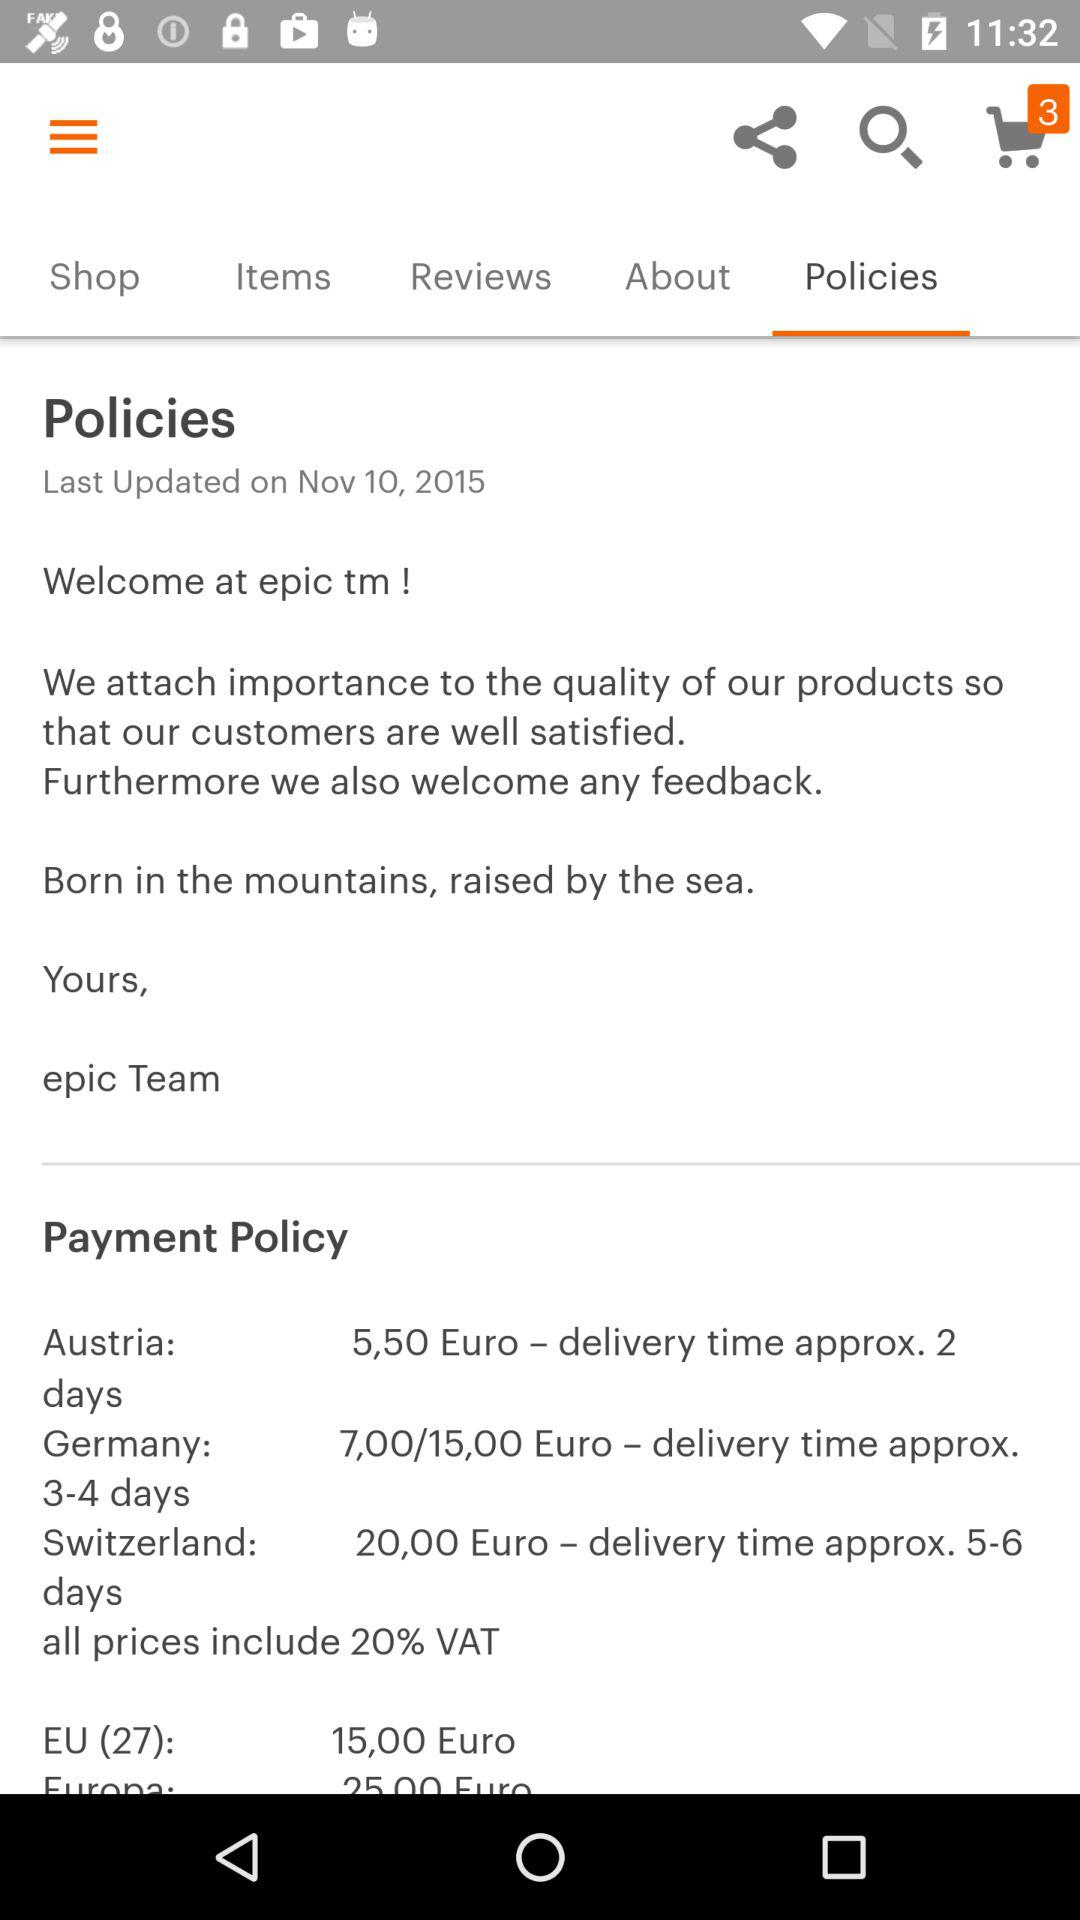What is the last updated date of the policies? The date is November 10, 2015. 